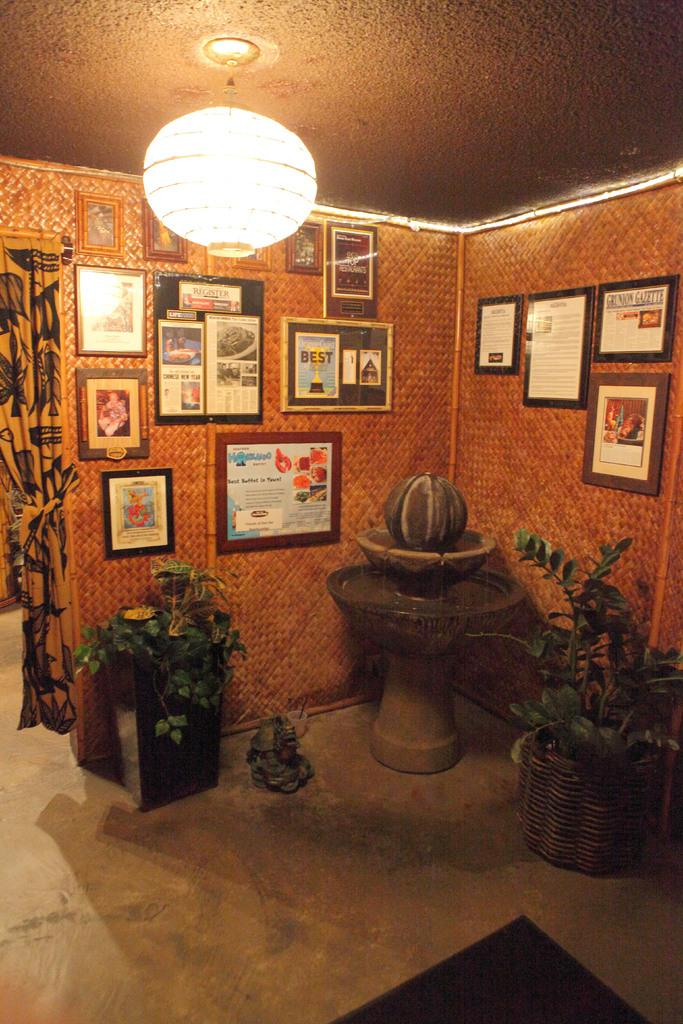What type of plants can be seen on the floor in the image? There are house plants on the floor in the image. What can be seen on the wall in the image? There are frames on the wall in the image. What type of window treatment is present in the image? There is a curtain in the image. What type of lighting is present in the image? There is a light hanging from the roof top in the image. What is on the floor in addition to the house plants? There is a mat and another object on the floor in the image. Can you tell me how many boats are visible in the image? There are no boats present in the image. What type of drain is visible in the image? There is no drain present in the image. 